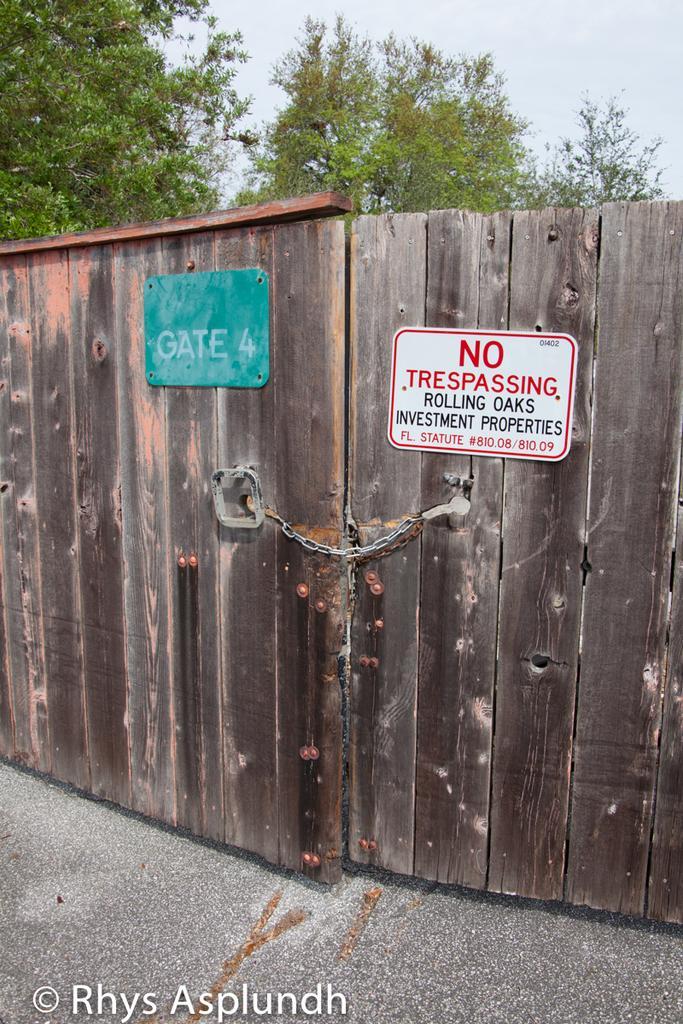Could you give a brief overview of what you see in this image? In this image there is a road. There is a wooden gate with chains. There are two boards with the text on the gate. There are trees in the background. There is a sky. 